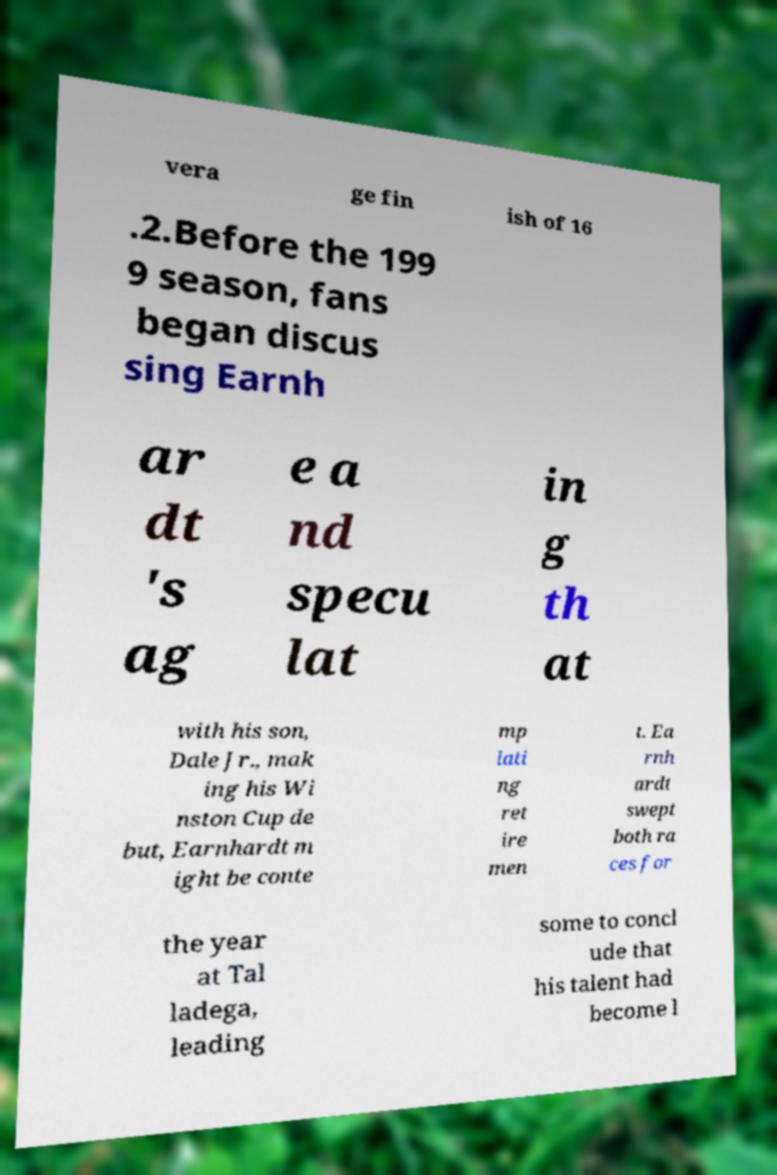I need the written content from this picture converted into text. Can you do that? vera ge fin ish of 16 .2.Before the 199 9 season, fans began discus sing Earnh ar dt 's ag e a nd specu lat in g th at with his son, Dale Jr., mak ing his Wi nston Cup de but, Earnhardt m ight be conte mp lati ng ret ire men t. Ea rnh ardt swept both ra ces for the year at Tal ladega, leading some to concl ude that his talent had become l 